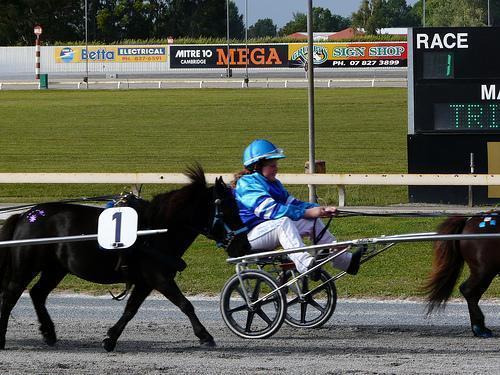How many wheels are on the cart?
Give a very brief answer. 2. 